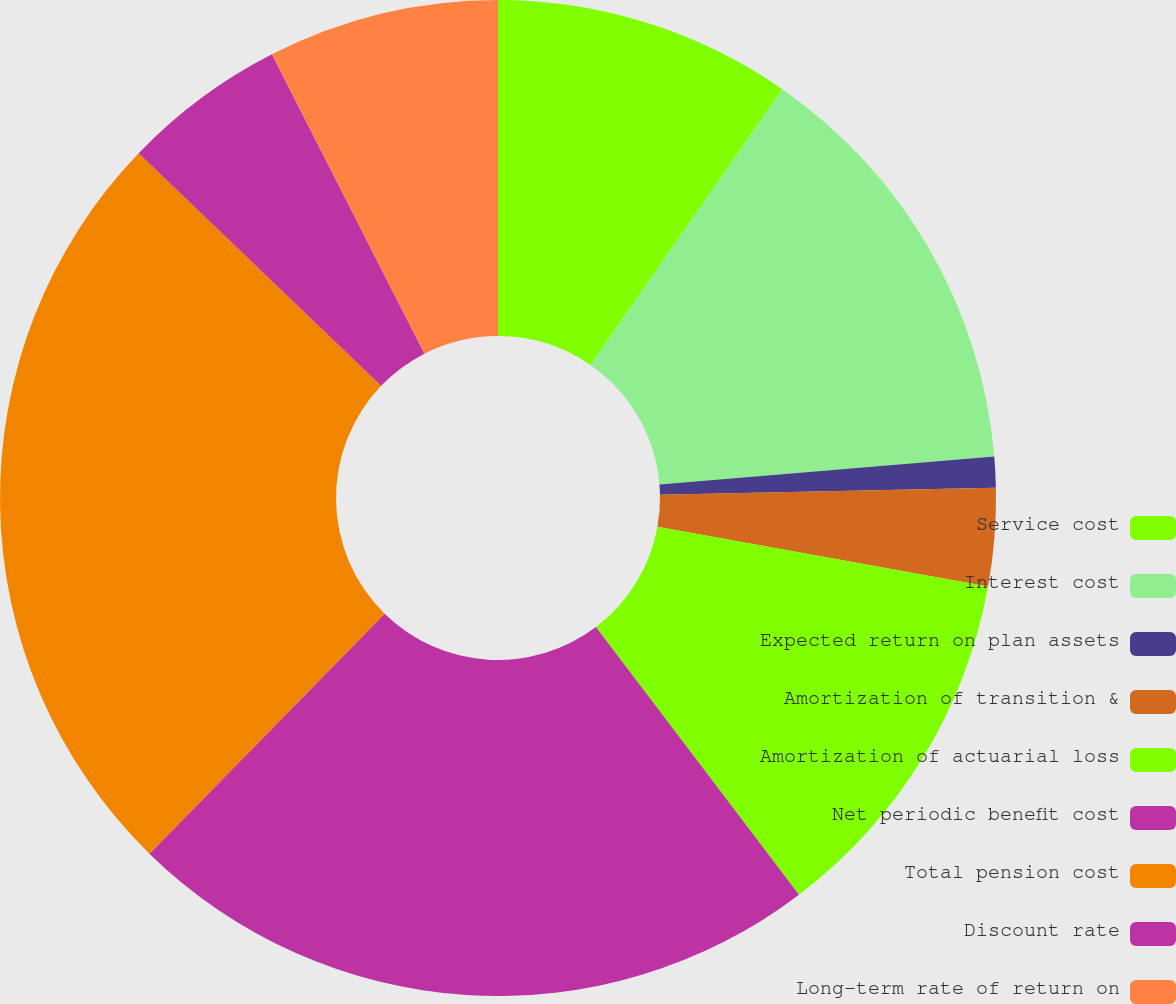<chart> <loc_0><loc_0><loc_500><loc_500><pie_chart><fcel>Service cost<fcel>Interest cost<fcel>Expected return on plan assets<fcel>Amortization of transition &<fcel>Amortization of actuarial loss<fcel>Net periodic benefit cost<fcel>Total pension cost<fcel>Discount rate<fcel>Long-term rate of return on<nl><fcel>9.67%<fcel>14.0%<fcel>1.0%<fcel>3.17%<fcel>11.83%<fcel>22.67%<fcel>24.83%<fcel>5.33%<fcel>7.5%<nl></chart> 